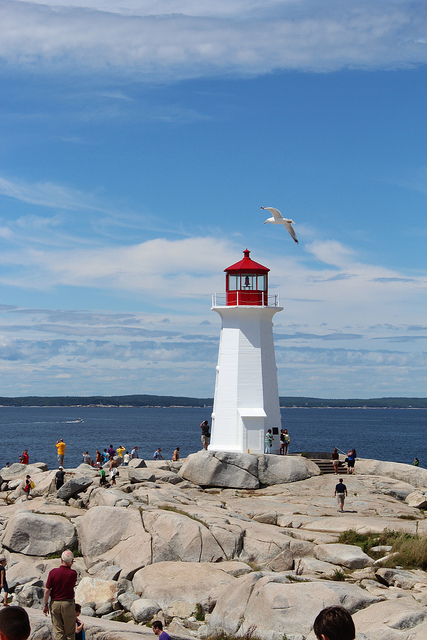What is the main structure featured in this image? The main structure is a white lighthouse with a red cap located on a rocky coastline. It serves as a navigational aid for vessels at sea, guiding their way with its prominent and distinct coloring. 